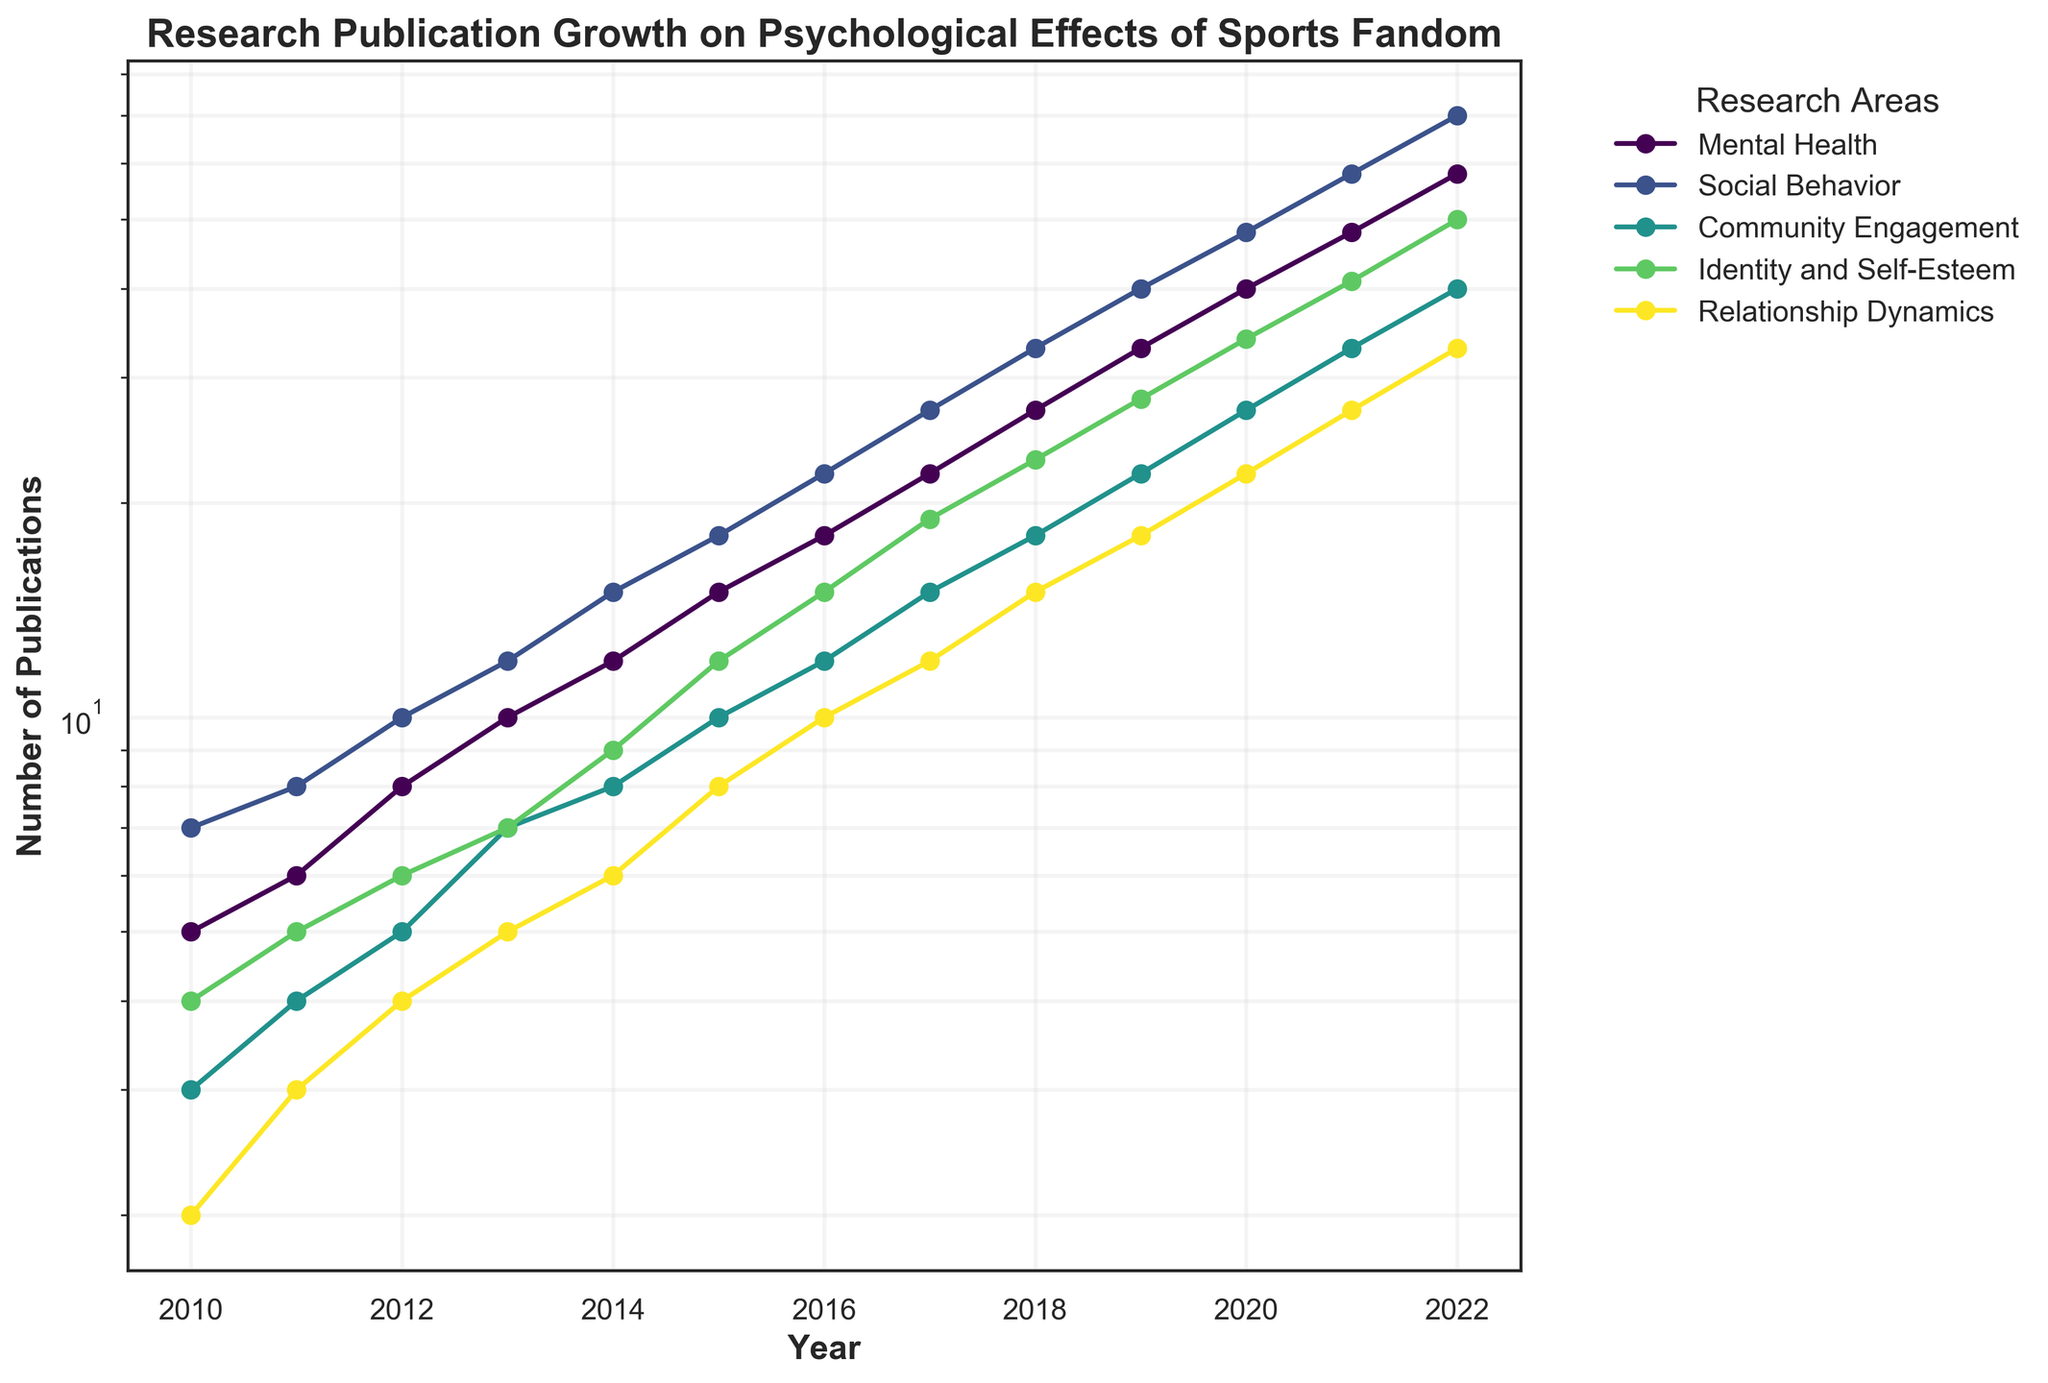What is the title of the plot? The title is displayed at the top of the figure and describes the subject of the plot.
Answer: Research Publication Growth on Psychological Effects of Sports Fandom Which research area has the highest number of publications in 2022? The number of publications for each research area in 2022 can be seen at the end of the corresponding line graph.
Answer: Mental Health What is the trend of publications in the 'Community Engagement' category over the decade? Look at the line graph for 'Community Engagement'; it shows an upward trend as the number of publications increases over time.
Answer: Increasing What was the number of publications for 'Social Behavior' in 2015? Trace the 'Social Behavior' line to the year 2015 and find the corresponding value on the y-axis.
Answer: 18 How does the growth in publications for 'Identity and Self-Esteem' compare to 'Relationship Dynamics' from 2010 to 2022? Check the slopes of the lines for both categories. 'Identity and Self-Esteem' shows a slightly steeper slope compared to 'Relationship Dynamics' over the same period.
Answer: Identity and Self-Esteem has grown faster What is the overall trend observed in the number of publications across all research areas? This involves observing all lines, which generally show an upward trend over time.
Answer: Increasing Between which years did 'Mental Health' publications exceed 20 for the first time? Trace the 'Mental Health' line to find where it crosses the 20 mark on the y-axis and note the corresponding years.
Answer: 2016 and 2017 How many years did it take for 'Relationship Dynamics' publications to reach 10? Start from 2010 and trace the line to find the first point where the number reaches 10.
Answer: 6 years (2016) On the log scale, by approximately how much did 'Community Engagement' publications increase from 2010 to 2022? Check the starting and ending values for 'Community Engagement' and find their ratio (log difference).
Answer: Increased by a factor of about 13 Which research area shows the most consistent growth, judging by the smoothness of its line? Investigate each line for smoothness and lack of abrupt changes; 'Mental Health' generally has a smooth and consistent upward trend.
Answer: Mental Health 